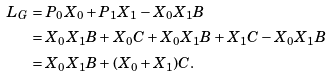Convert formula to latex. <formula><loc_0><loc_0><loc_500><loc_500>L _ { G } & = P _ { 0 } X _ { 0 } + P _ { 1 } X _ { 1 } - X _ { 0 } X _ { 1 } B \\ & = X _ { 0 } X _ { 1 } B + X _ { 0 } C + X _ { 0 } X _ { 1 } B + X _ { 1 } C - X _ { 0 } X _ { 1 } B \\ & = X _ { 0 } X _ { 1 } B + ( X _ { 0 } + X _ { 1 } ) C .</formula> 